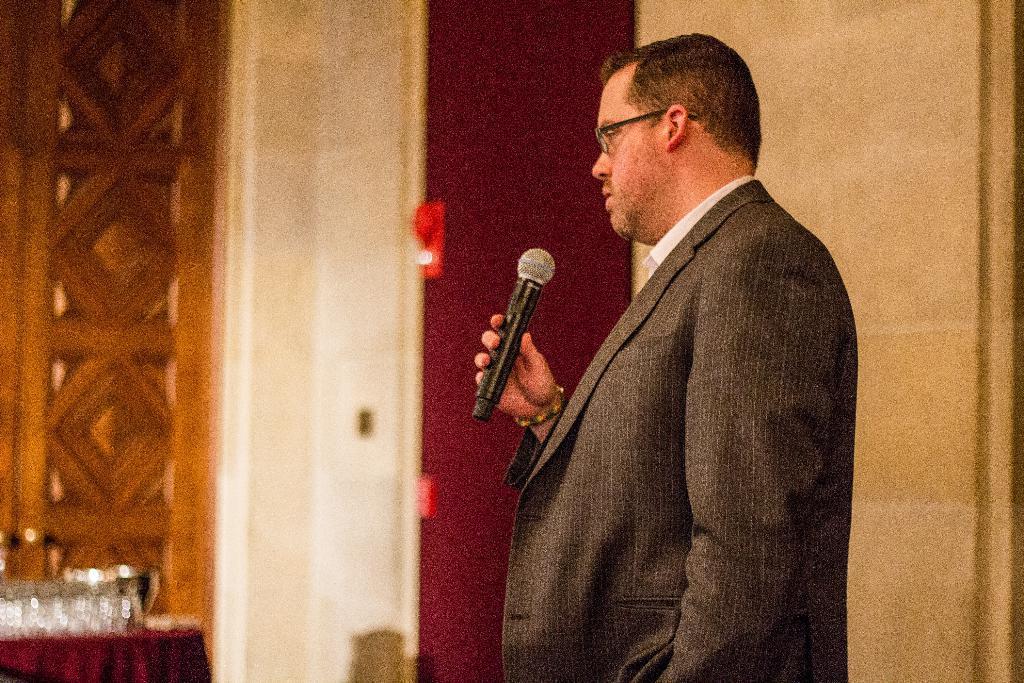Could you give a brief overview of what you see in this image? In this picture we can see a man wearing a spectacles and he is holding a mike in his hand. Here we can see glasses on the table. This is a wall. 